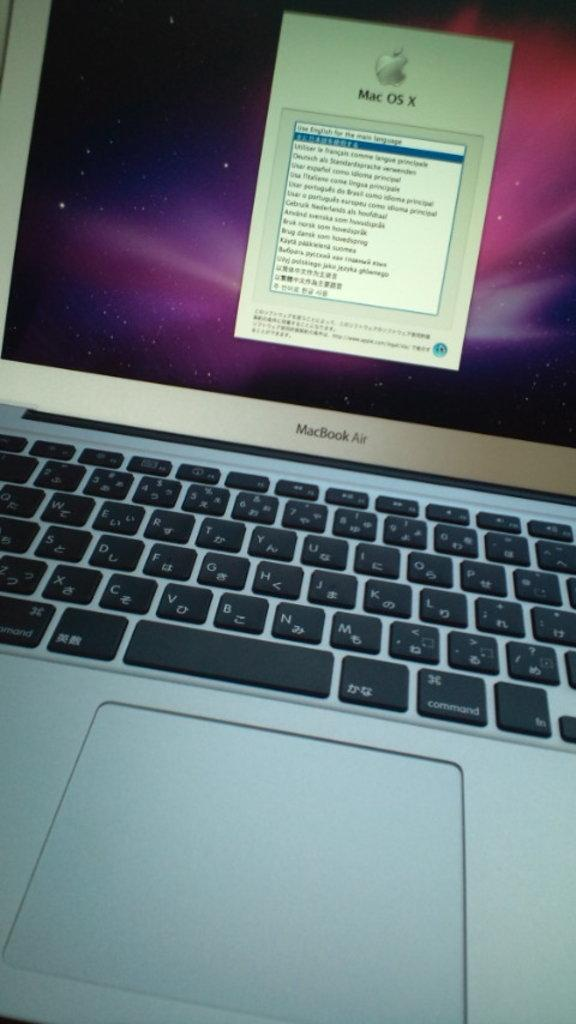<image>
Describe the image concisely. An open silver MacBook Air laptop with black keys. 